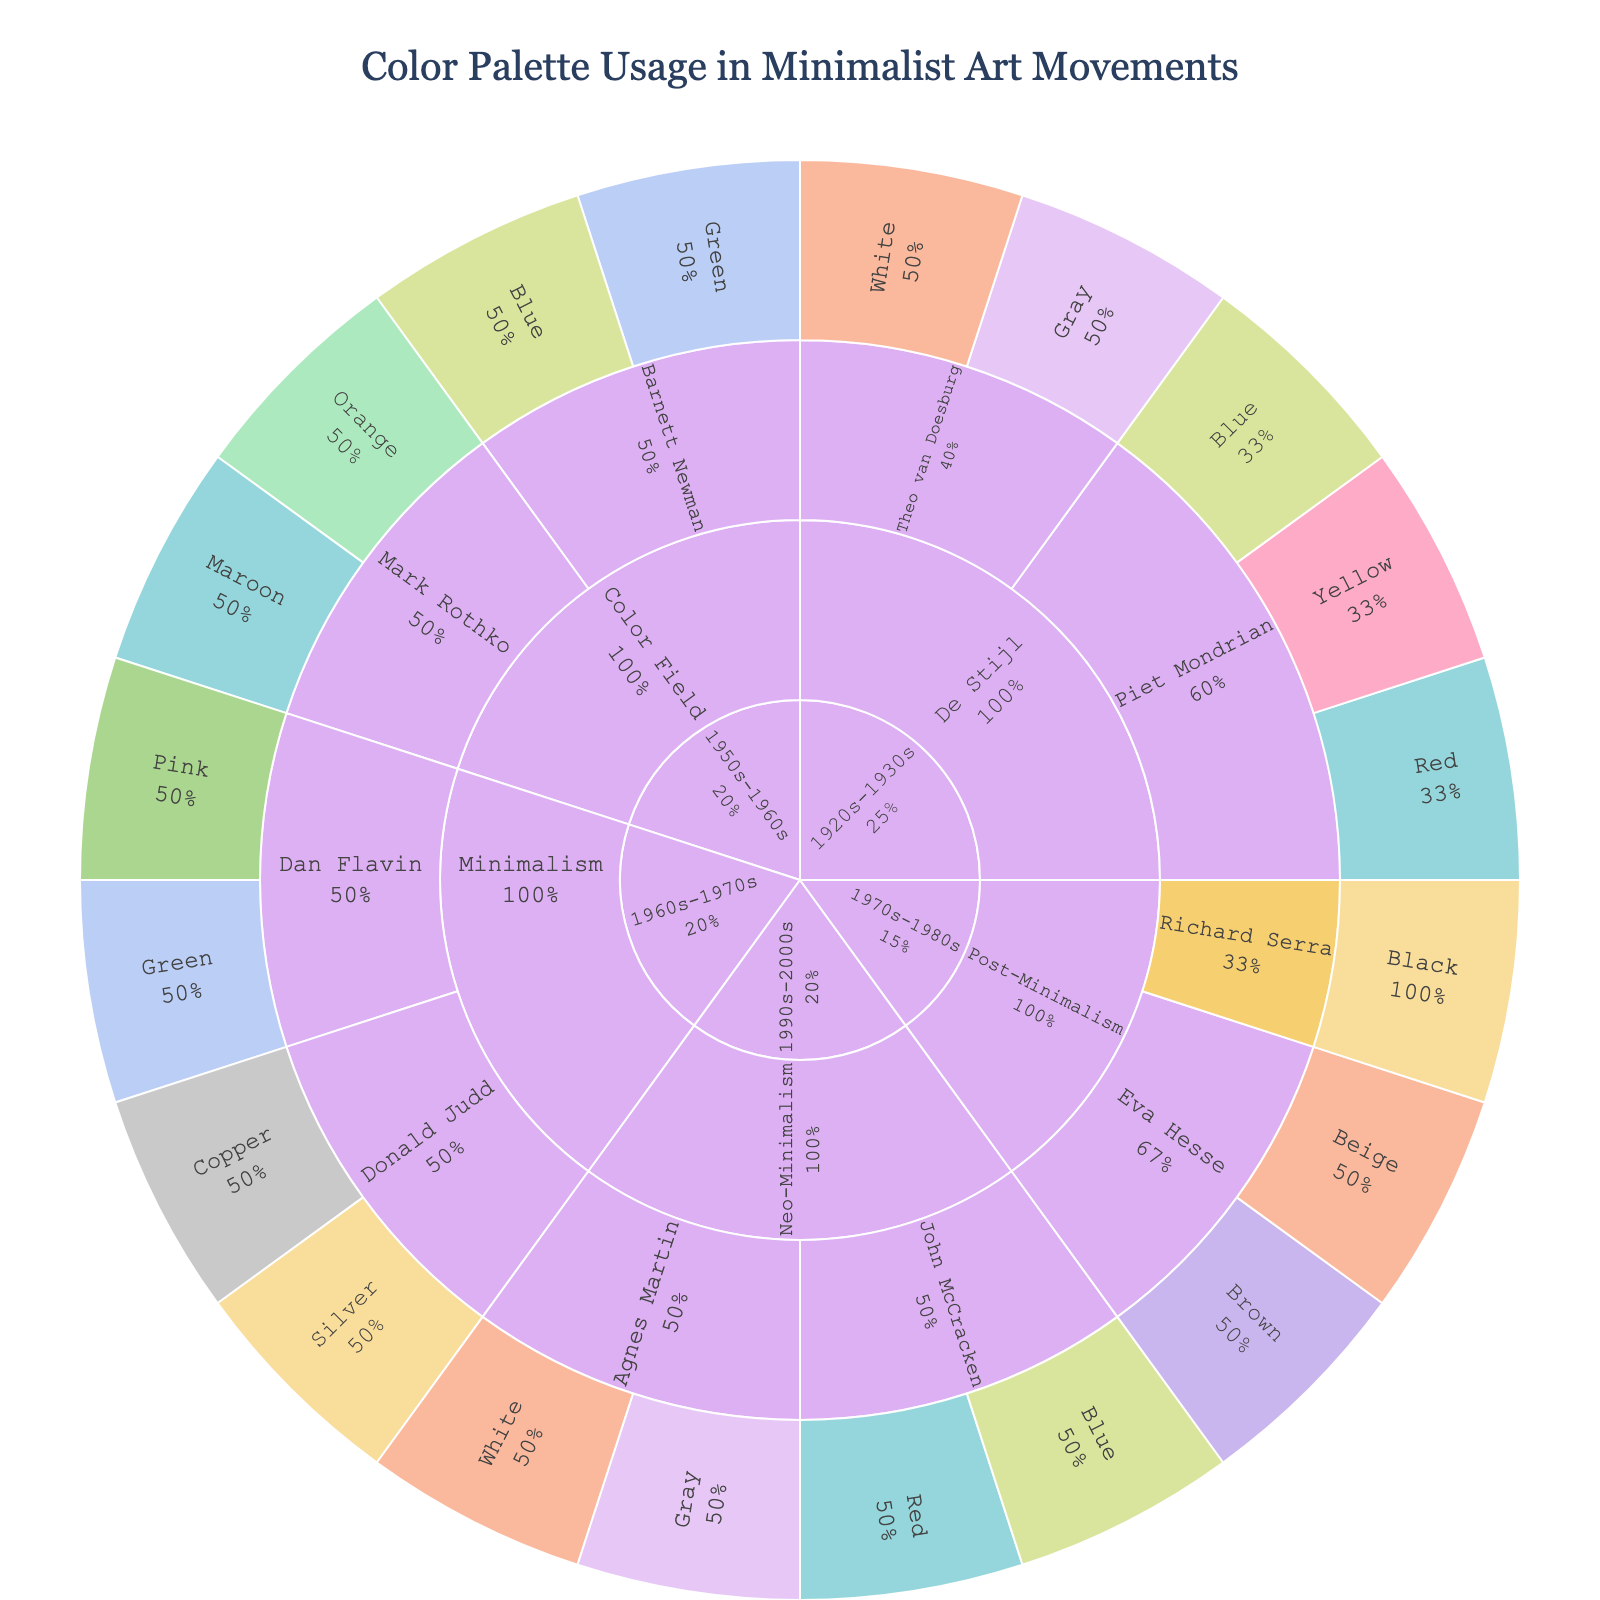what is the name of the plot in the figure? The title of the plot is prominently displayed at the top of the figure. Upon reading it, one can find the name of the plot.
Answer: Color Palette Usage in Minimalist Art Movements Which color is used by Piet Mondrian in the De Stijl movement? The figure breaks down the De Stijl movement by artist, then by their color usage. Under Piet Mondrian, the colors are red, blue, and yellow.
Answer: Red, Blue, Yellow How many colors are used by artists in the Neo-Minimalism movement? In the sunburst plot, locate the Neo-Minimalism section, then count the colors listed under each artist in that movement. John McCracken uses two and Agnes Martin uses two, making a total of four colors.
Answer: Four Which era has the least number of referenced colors and which has the most? Analyze the sunburst sections representing each era and count the colors within each. The 1920s-1930s and 1990s-2000s both have the least with five colors each. The 1970s-1980s, with artists Eva Hesse and Richard Serra, collectively utilize the most colors.
Answer: 1990s-2000s (least), 1970s-1980s (most) Compare the use of color between Theo van Doesburg and Dan Flavin. Who uses a more diverse palette? By examining the sections for Theo van Doesburg and Dan Flavin, count the different colors each artist uses. Theo van Doesburg uses white and gray (two colors), while Dan Flavin uses pink and green (two colors). Both artists use an equally diverse palette.
Answer: Equally diverse What percentage of the colors used by artists in the 1950s-1960s Color Field movement is orange? Locate the 1950s-1960s era and within it, the Color Field movement. Mark Rothko uses orange, and there are a total of four colors (maroon, orange, blue, and green) used within Color Field. Therefore, the percentage is \(\frac{1}{4} \times 100\%\).
Answer: 25% What percentage of the colors in the Minimalism movement are green? In the Minimalism movement within the sunburst plot, Dan Flavin's use of green constitutes one out of the four colors (silver, copper, pink, green). Thus, the percentage is \(\frac{1}{4} \times 100\%\).
Answer: 25% Are there any artists who use identical color palettes in different eras? Cross-reference the artist's color palettes under different eras. Piet Mondrian's red, blue, and yellow in De Stijl and John McCracken's red and blue in Neo-Minimalism are repeated palette combinations, confirming no identical replication across multiple eras by the same artist.
Answer: No How does the color usage by Richard Serra compare to that of Agnes Martin in terms of greyscale representation? Richard Serra uses black, and Agnes Martin uses white and gray. While both employ greyscale tones, Agnes Martin includes two shades (white and gray), resulting in a more varied greyscale representation.
Answer: Agnes Martin What's the total count of colors within the 1960s-1970s Minimalism movement? In the 1960s-1970s Minimalism movement section of the sunburst, adding up Donald Judd's two colors and Dan Flavin's two colors gives a total of four colors.
Answer: Four 